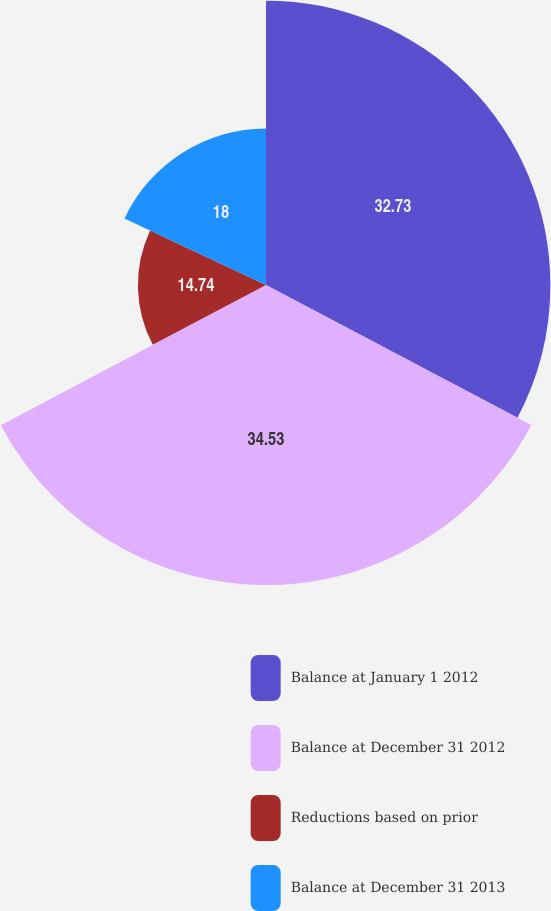<chart> <loc_0><loc_0><loc_500><loc_500><pie_chart><fcel>Balance at January 1 2012<fcel>Balance at December 31 2012<fcel>Reductions based on prior<fcel>Balance at December 31 2013<nl><fcel>32.73%<fcel>34.53%<fcel>14.74%<fcel>18.0%<nl></chart> 